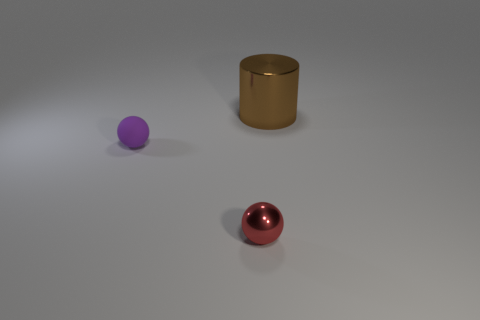What materials seem to be depicted in the objects shown in the image? The objects in the image appear to be made of different materials. The sphere in the foreground has a glossy finish that suggests it could be metallic, possibly steel or polished chrome. The cylinder in the middle looks like it could be made of brushed metal, perhaps brass or bronze. The purple sphere has a matte finish and is likely a plastic or painted wood. 